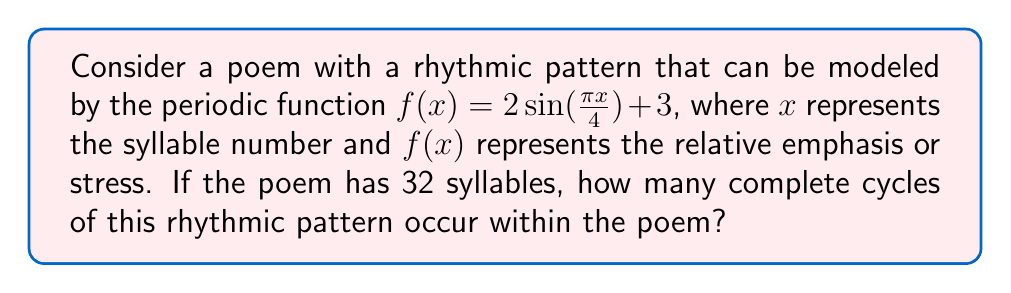Provide a solution to this math problem. To solve this problem, we need to follow these steps:

1. Identify the period of the given function:
   The general form of a sine function is $a\sin(bx) + c$, where the period is given by $\frac{2\pi}{|b|}$.
   In our case, $b = \frac{\pi}{4}$, so the period is:
   $$\text{Period} = \frac{2\pi}{|\frac{\pi}{4}|} = 8$$

2. Determine the number of syllables in one complete cycle:
   One cycle of the rhythmic pattern takes 8 syllables.

3. Calculate the number of complete cycles in the poem:
   $$\text{Number of cycles} = \frac{\text{Total syllables}}{\text{Syllables per cycle}} = \frac{32}{8} = 4$$

Therefore, there are 4 complete cycles of the rhythmic pattern within the 32-syllable poem.
Answer: 4 cycles 